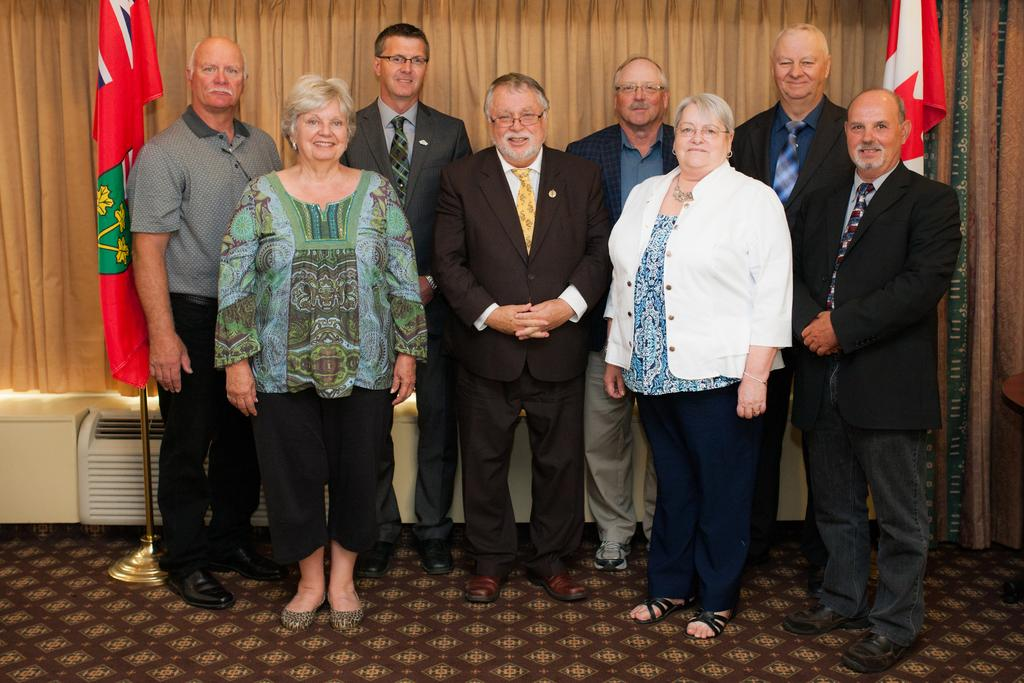How many people are in the image? There are people in the image, but the exact number is not specified. What are the people doing in the image? The people are standing and smiling in the image. What can be seen in the background of the image? In the background of the image, there are flags, curtains, and objects. What is visible at the bottom of the image? The floor is visible at the bottom of the image. What type of book is being read by the person in the image? There is no person reading a book in the image. What time of day is depicted in the image? The time of day is not specified in the image. Is there any milk visible in the image? There is no milk present in the image. 